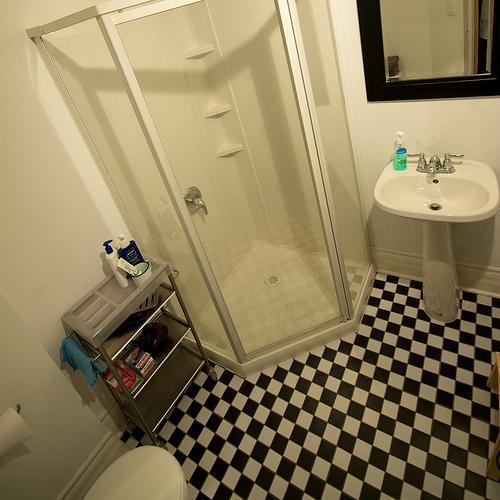How many sinks are there?
Give a very brief answer. 1. How many showers are in the bathroom?
Give a very brief answer. 1. 